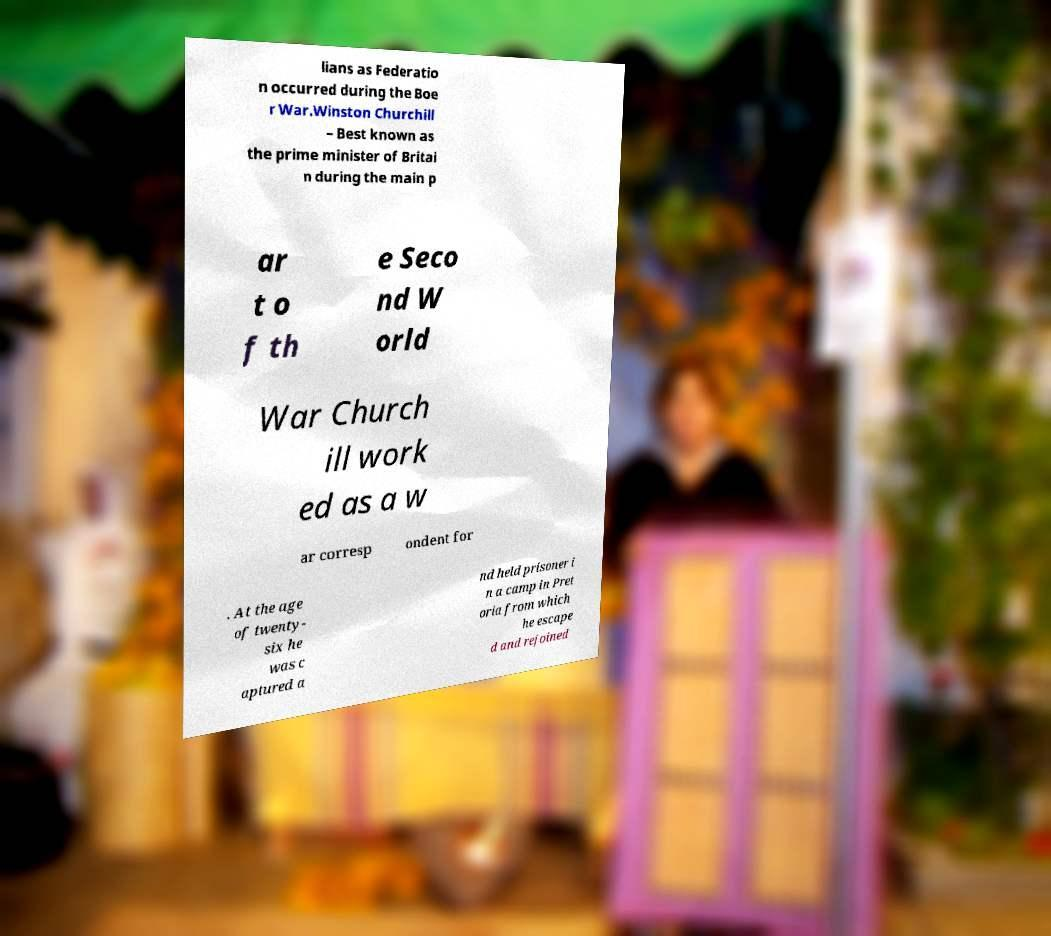Could you assist in decoding the text presented in this image and type it out clearly? lians as Federatio n occurred during the Boe r War.Winston Churchill – Best known as the prime minister of Britai n during the main p ar t o f th e Seco nd W orld War Church ill work ed as a w ar corresp ondent for . At the age of twenty- six he was c aptured a nd held prisoner i n a camp in Pret oria from which he escape d and rejoined 